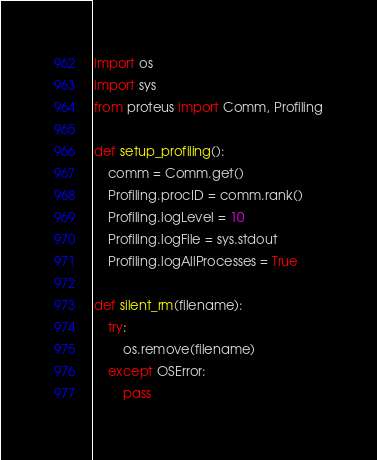<code> <loc_0><loc_0><loc_500><loc_500><_Python_>import os
import sys
from proteus import Comm, Profiling

def setup_profiling():
    comm = Comm.get()
    Profiling.procID = comm.rank()
    Profiling.logLevel = 10
    Profiling.logFile = sys.stdout
    Profiling.logAllProcesses = True

def silent_rm(filename):
    try:
        os.remove(filename)
    except OSError:
        pass</code> 